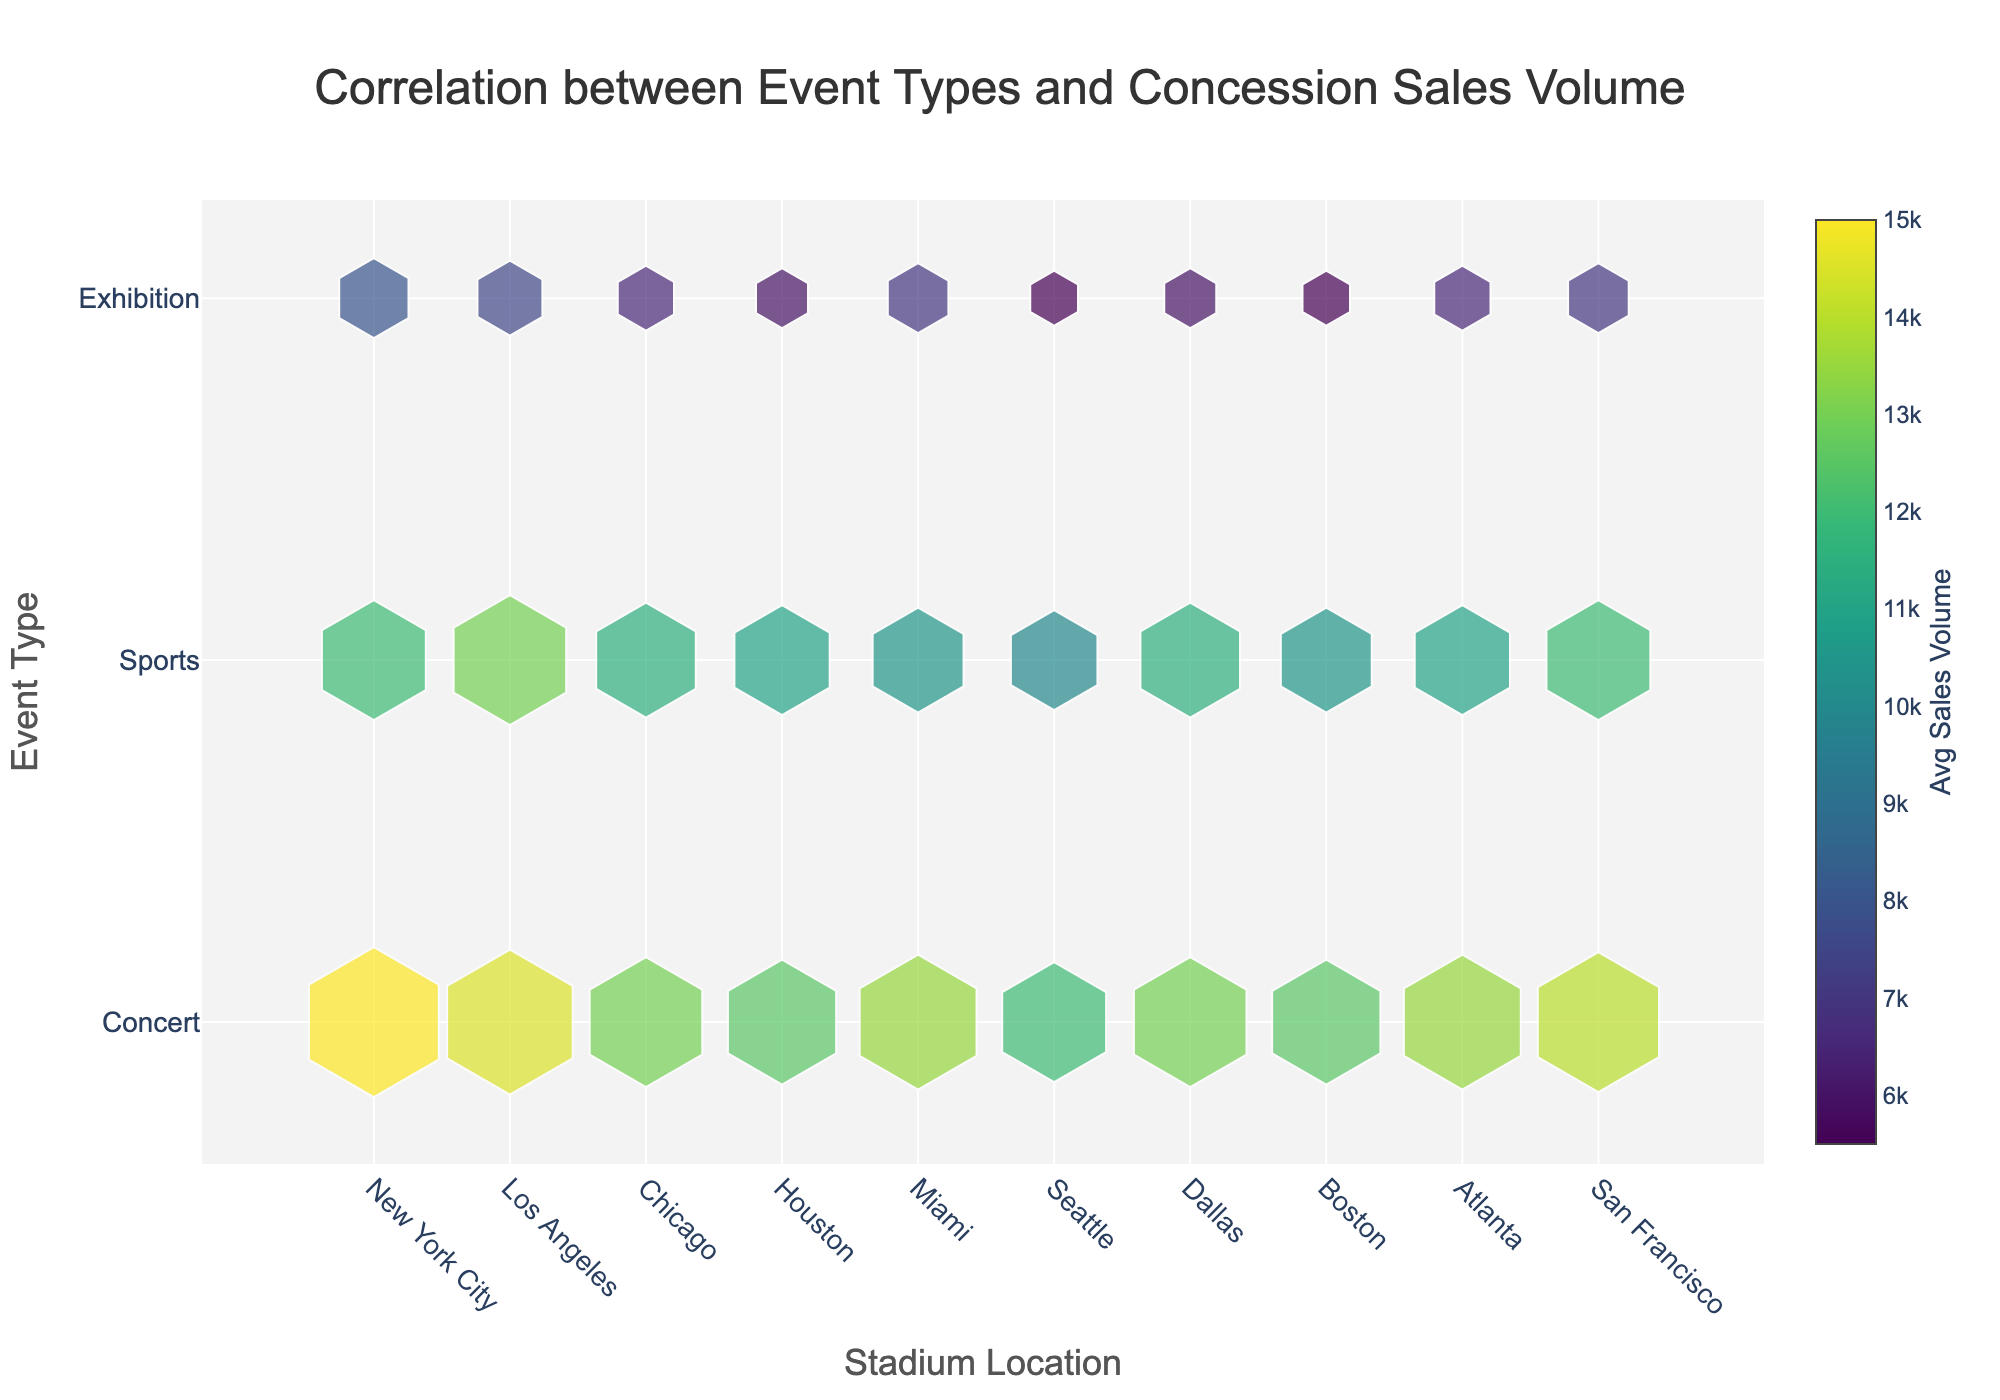What event type had the highest average concession sales volume in New York City? By hovering over the hexagons for New York City across different event types, you can find that Concert has the highest average sales volume of 15000.
Answer: Concert Which stadium location had the lowest average concession sales for Exhibitions? Examining the hexagons for Exhibitions in different locations, Seattle and Boston have the lowest average sales volume of 5500.
Answer: Seattle, Boston What's the difference in average concession sales volume between Concerts and Sports events in Miami? The average sales volume for Concerts in Miami is 13500 and for Sports is 10500. The difference is 13500 - 10500 = 3000.
Answer: 3000 Compare the average concession sales volume for Exhibitions in Los Angeles and Houston. Which is higher? Hovering over the hexagons for Exhibitions in Los Angeles and Houston shows average sales volumes of 7500 and 6000 respectively. 7500 is higher than 6000.
Answer: Los Angeles Identify the stadium location with the highest average concession sales volume for Sports events. By comparing the hexagons' average sales values for Sports events across all locations, San Francisco stands out with 12000 as the highest value.
Answer: San Francisco Which event type consistently shows the highest average concession sales volume across most stadium locations? By examining the hexagons for different event types across various locations, Concerts consistently have higher sales volumes than Sports and Exhibitions.
Answer: Concerts What's the combined average concession sales volume for Exhibitions in New York City and Miami? The average sales volume for Exhibitions in New York City is 8000 and in Miami is 7000. Their combined average is (8000 + 7000) / 2 = 7500.
Answer: 7500 How does the average concession sales volume for Sports events in Los Angeles compare to that in Atlanta? Hovering over the respective hexagons shows that the volume in Los Angeles is 13000 and in Atlanta is 11000. Los Angeles has a higher average.
Answer: Los Angeles Which stadium location has the smallest overall average concession sales volume when considering all event types together? To find this, calculate the overall average for each location and compare. Seattle, having comparatively lower sales volumes for all event types, has the smallest overall average.
Answer: Seattle 